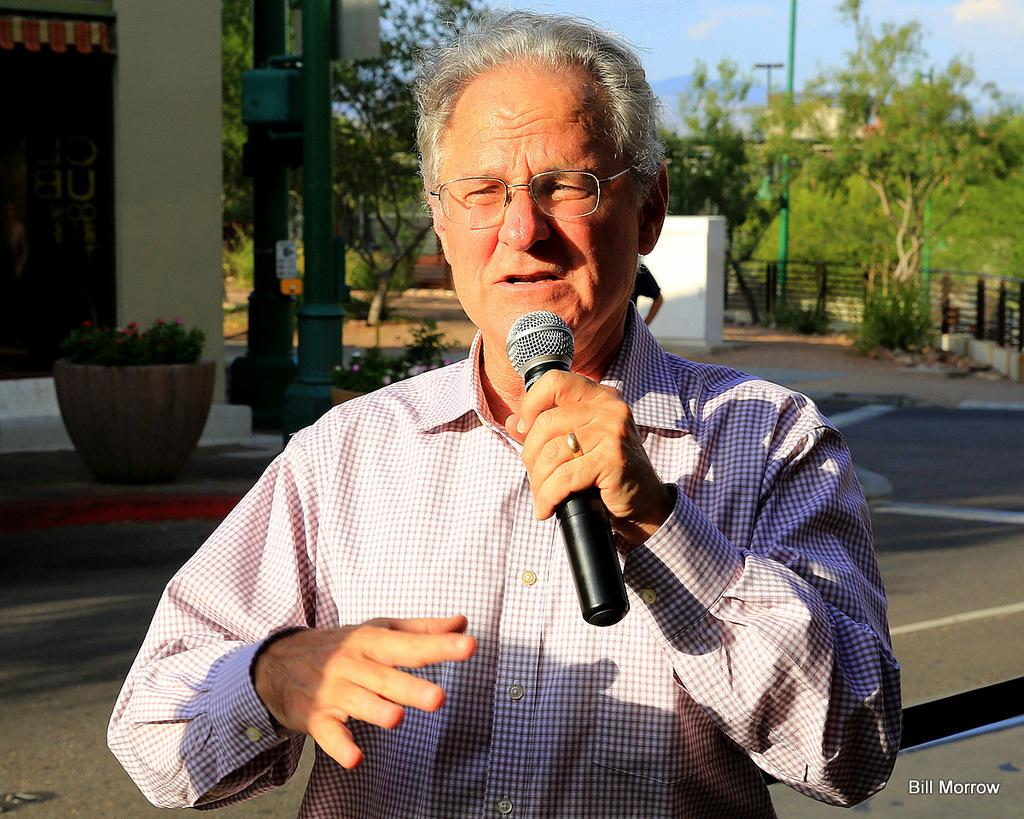What is the man doing in the image? The man is standing on the road and talking. What is the man holding in the image? The man is holding a microphone. What can be seen in the background of the image? There is a small plant, a door, a wall, a pole, and the sky visible in the background. What type of flight is the man taking in the image? There is no airplane or flight present in the image; it features a man standing on the road and talking. What sense is the man using to communicate with the microphone? The image does not provide information about the sense the man is using to communicate with the microphone. 